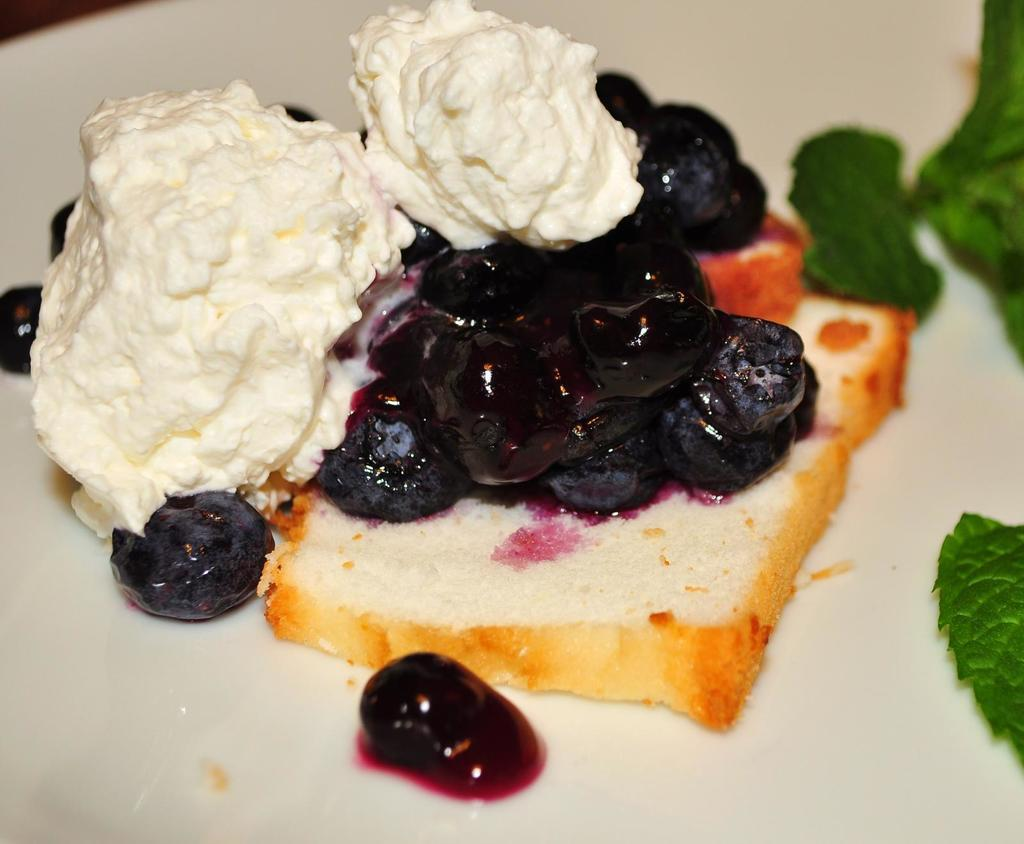What is the main food item in the image? There is a piece of bread in the image. What is on top of the bread? There are food items on the bread, including ice cream. What is the color of the surface the bread is on? The surface the bread is on is white. What type of vegetation can be seen in the image? There are leaves in the image. What type of wash is being used to clean the leaves in the image? There is no indication of any washing or cleaning activity involving the leaves in the image. The leaves are simply present in the image. 